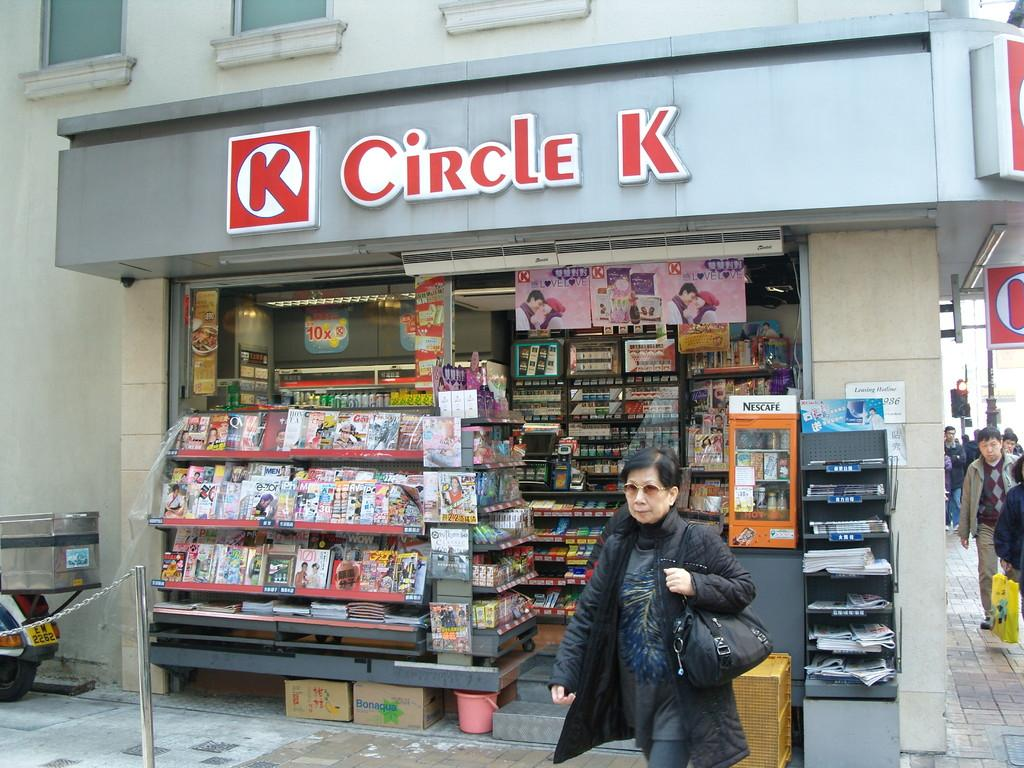<image>
Describe the image concisely. An Circle K new stand that has magazines displayed near the sidewalk where pedestrians are walking. 